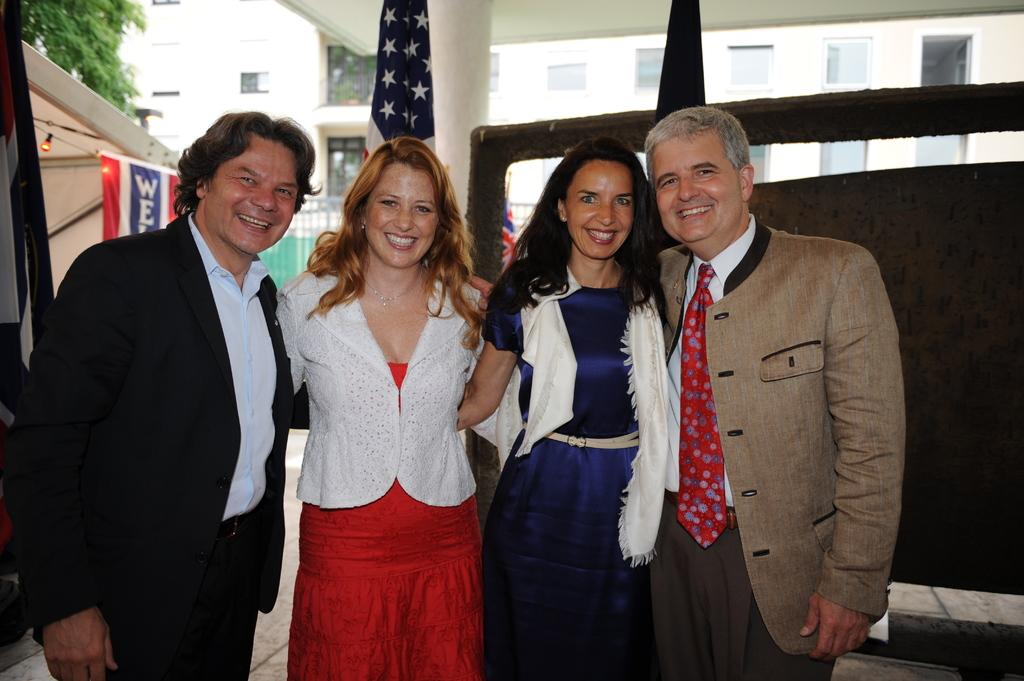How many people are present in the image? There are four persons standing in the image. What is the facial expression of the people in the image? The persons are smiling. What can be seen in the image besides the people? There are flags, a banner, a tree, and a building in the background of the image. What type of yak can be seen grazing near the tree in the image? There is no yak present in the image; it only features four people, flags, a banner, a tree, and a building in the background. 